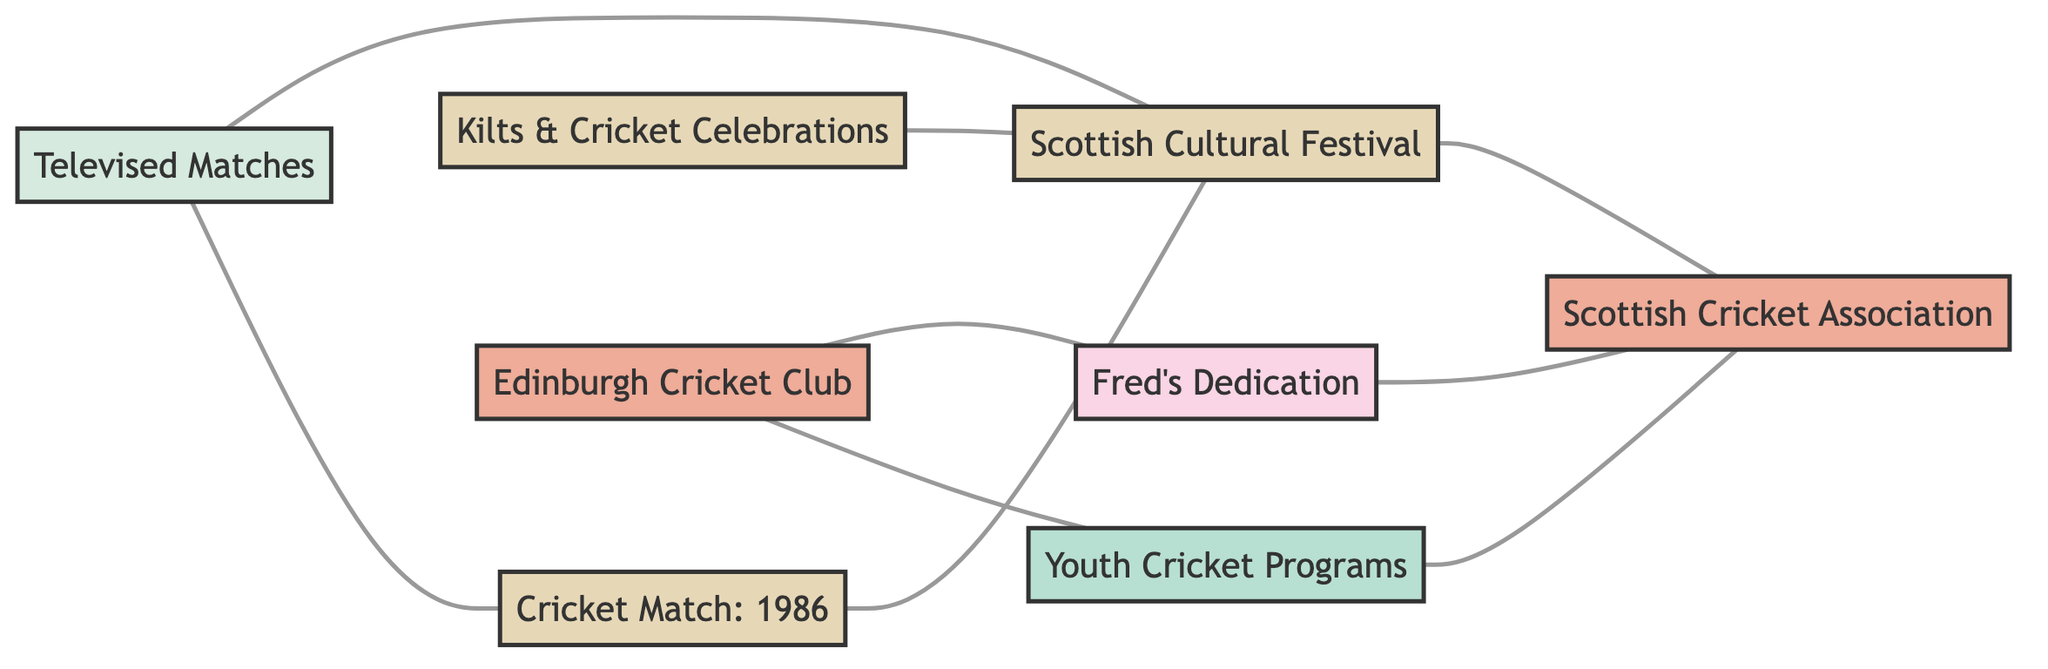What is the total number of nodes in the diagram? The diagram lists several entities which represent people, organizations, events, initiatives, and media. Counting them gives us a total of 8 nodes in the diagram.
Answer: 8 Who inspired the foundation of the Scottish Cricket Association? The connection labeled "Inspired Foundation" between Fred's Dedication and the Scottish Cricket Association indicates that Fred's Dedication inspired the foundation of the association.
Answer: Fred's Dedication Which event is considered a major highlight of the Scottish Cultural Festival? The edge linking the Cricket Match: 1986 and the Scottish Cultural Festival is labeled "Major Highlight," indicating that this event is highlighted within the festival's context.
Answer: Cricket Match: 1986 What organization runs the Youth Cricket Programs? The Edinburgh Cricket Club is connected to Youth Cricket Programs with the edge labeled "Runs," indicating that the club is responsible for running these programs.
Answer: Edinburgh Cricket Club What event is recurring at the Scottish Cultural Festival? The connection between Kilts & Cricket Celebrations and the Scottish Cultural Festival is labeled "Recurring Event," indicating that this specific celebration occurs regularly as part of the festival.
Answer: Kilts & Cricket Celebrations Which media increases viewership for the Scottish Cultural Festival? There is a direct link labeled "Increases Viewership" from Televised Matches to the Scottish Cultural Festival, suggesting that televised matches help to bolster the audience for the festival's events.
Answer: Televised Matches How many edges are there in the diagram? The diagram shows multiple connections between nodes (edges). Counting these connections shows that there are 9 edges altogether in the diagram.
Answer: 9 What relationship does the Scottish Cultural Festival have with the Scottish Cricket Association? The edge between the Scottish Cultural Festival and the Scottish Cricket Association is labeled "Organizes Cricket Events," indicating a direct organizational relationship where the festival organizes cricket-related events.
Answer: Organizes Cricket Events What is the influence of televised matches on the Cricket Match held in 1986? There is a direct connection labeled "Broadcasted" from Televised Matches to Cricket Match: 1986, indicating that this match was broadcasted, showcasing the influence of media on this specific event.
Answer: Broadcasted 